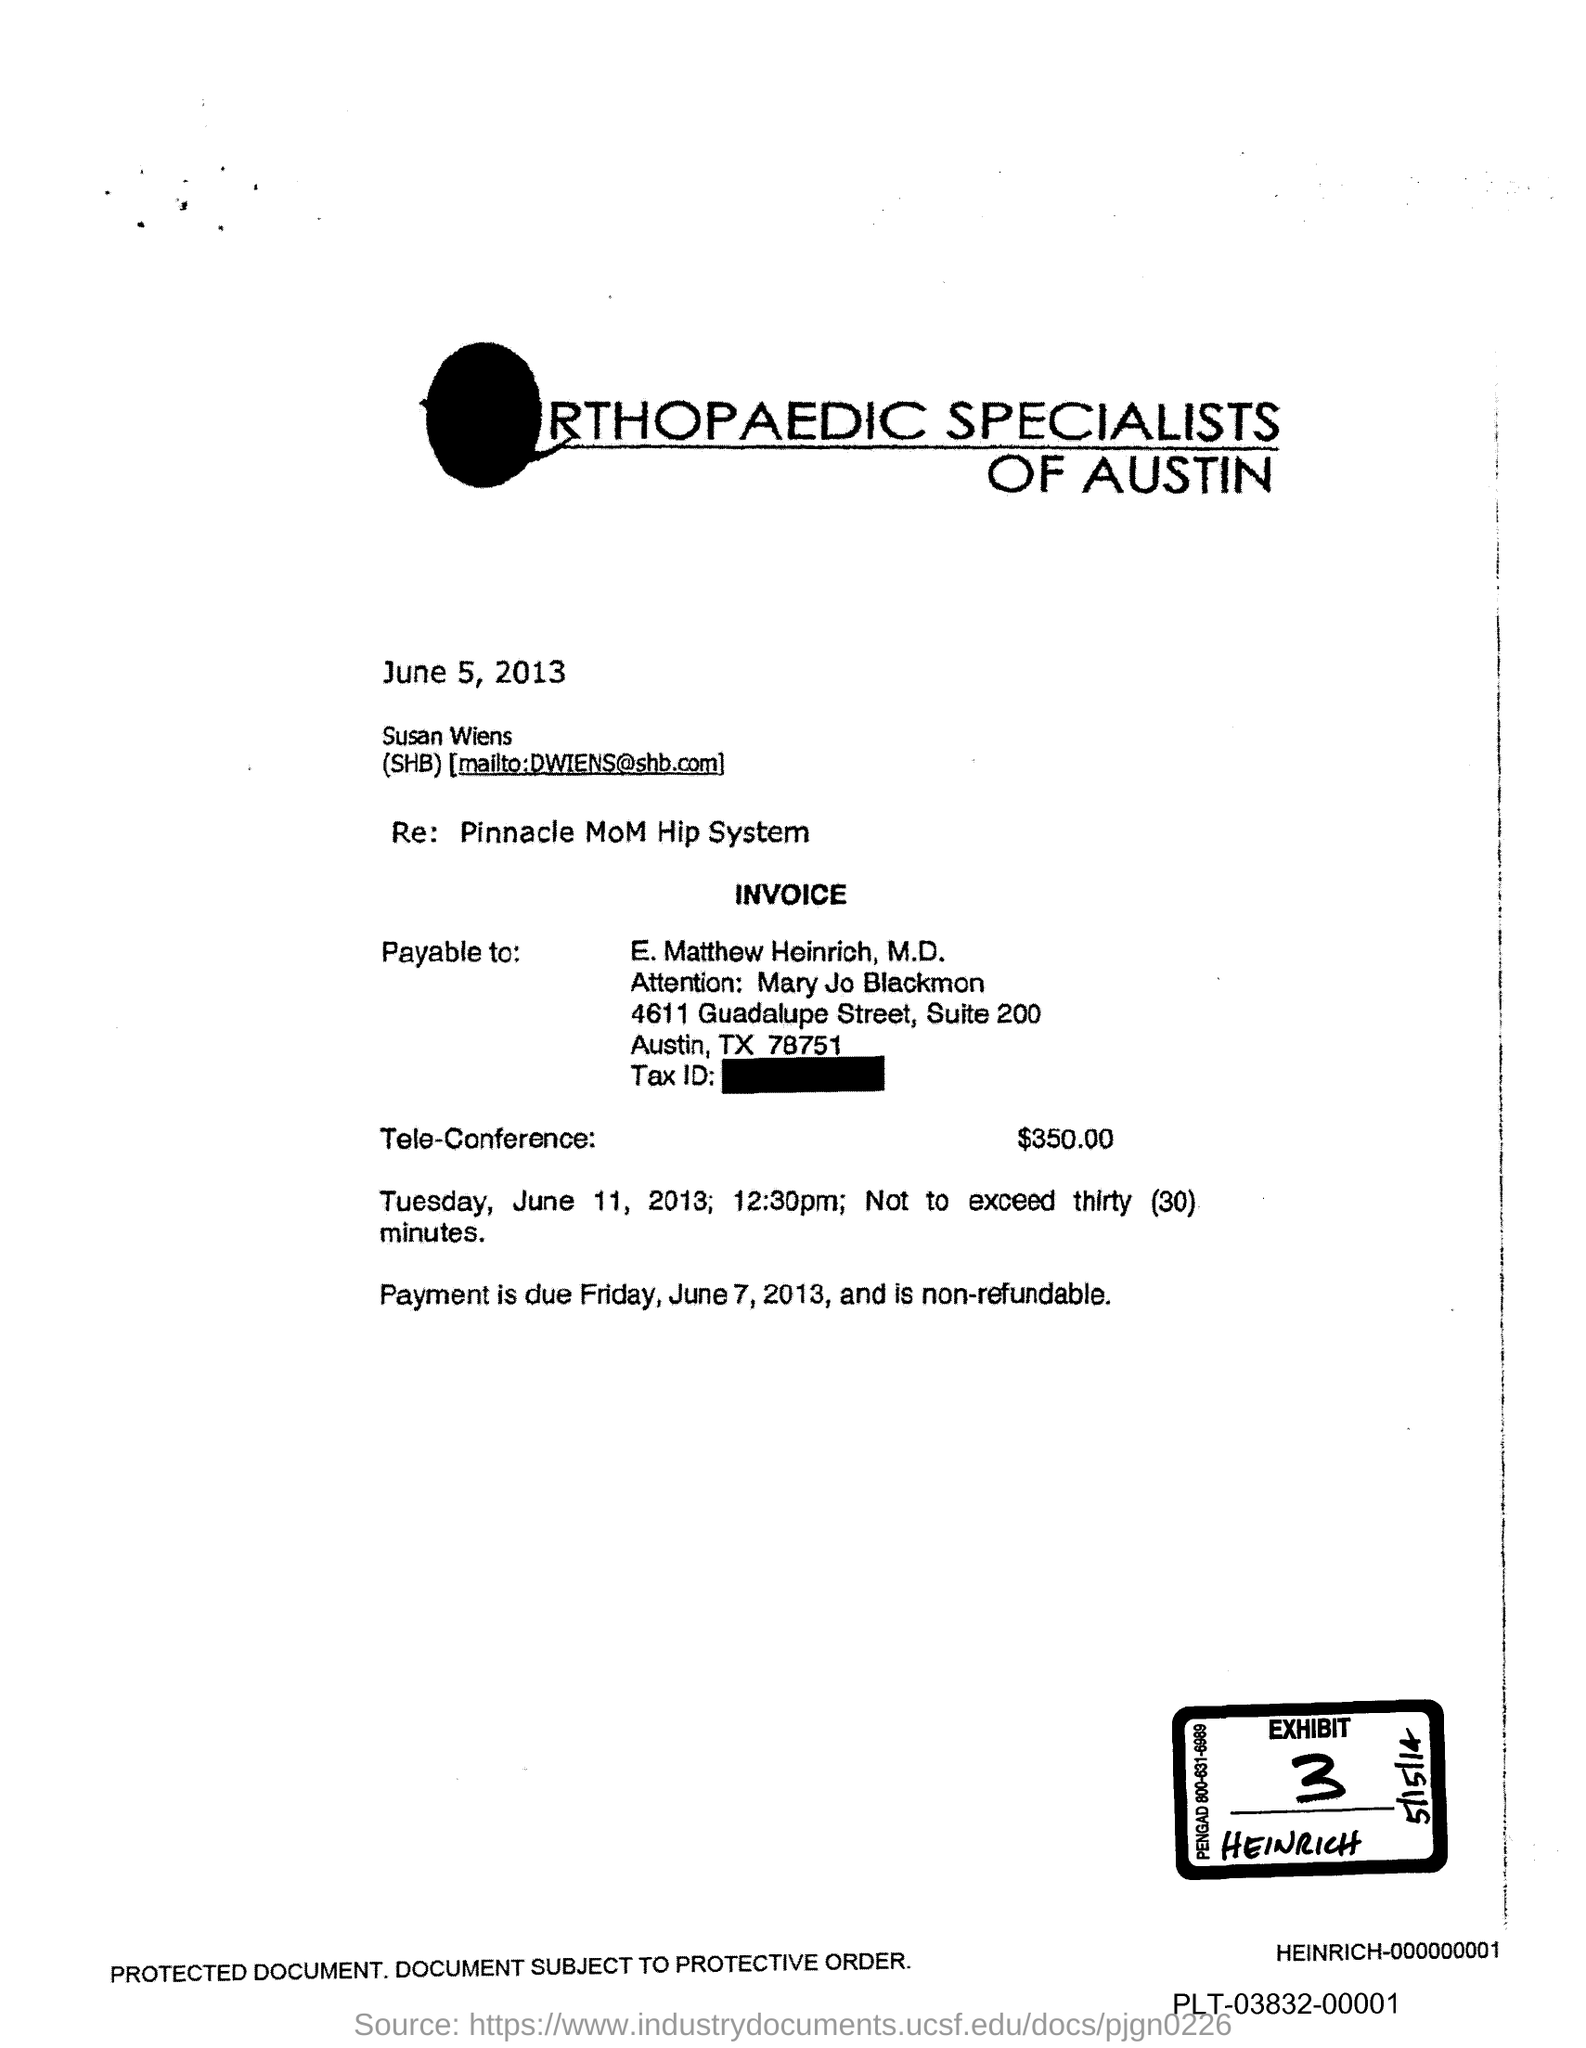What is the Exhibit number?
Provide a short and direct response. 3. 